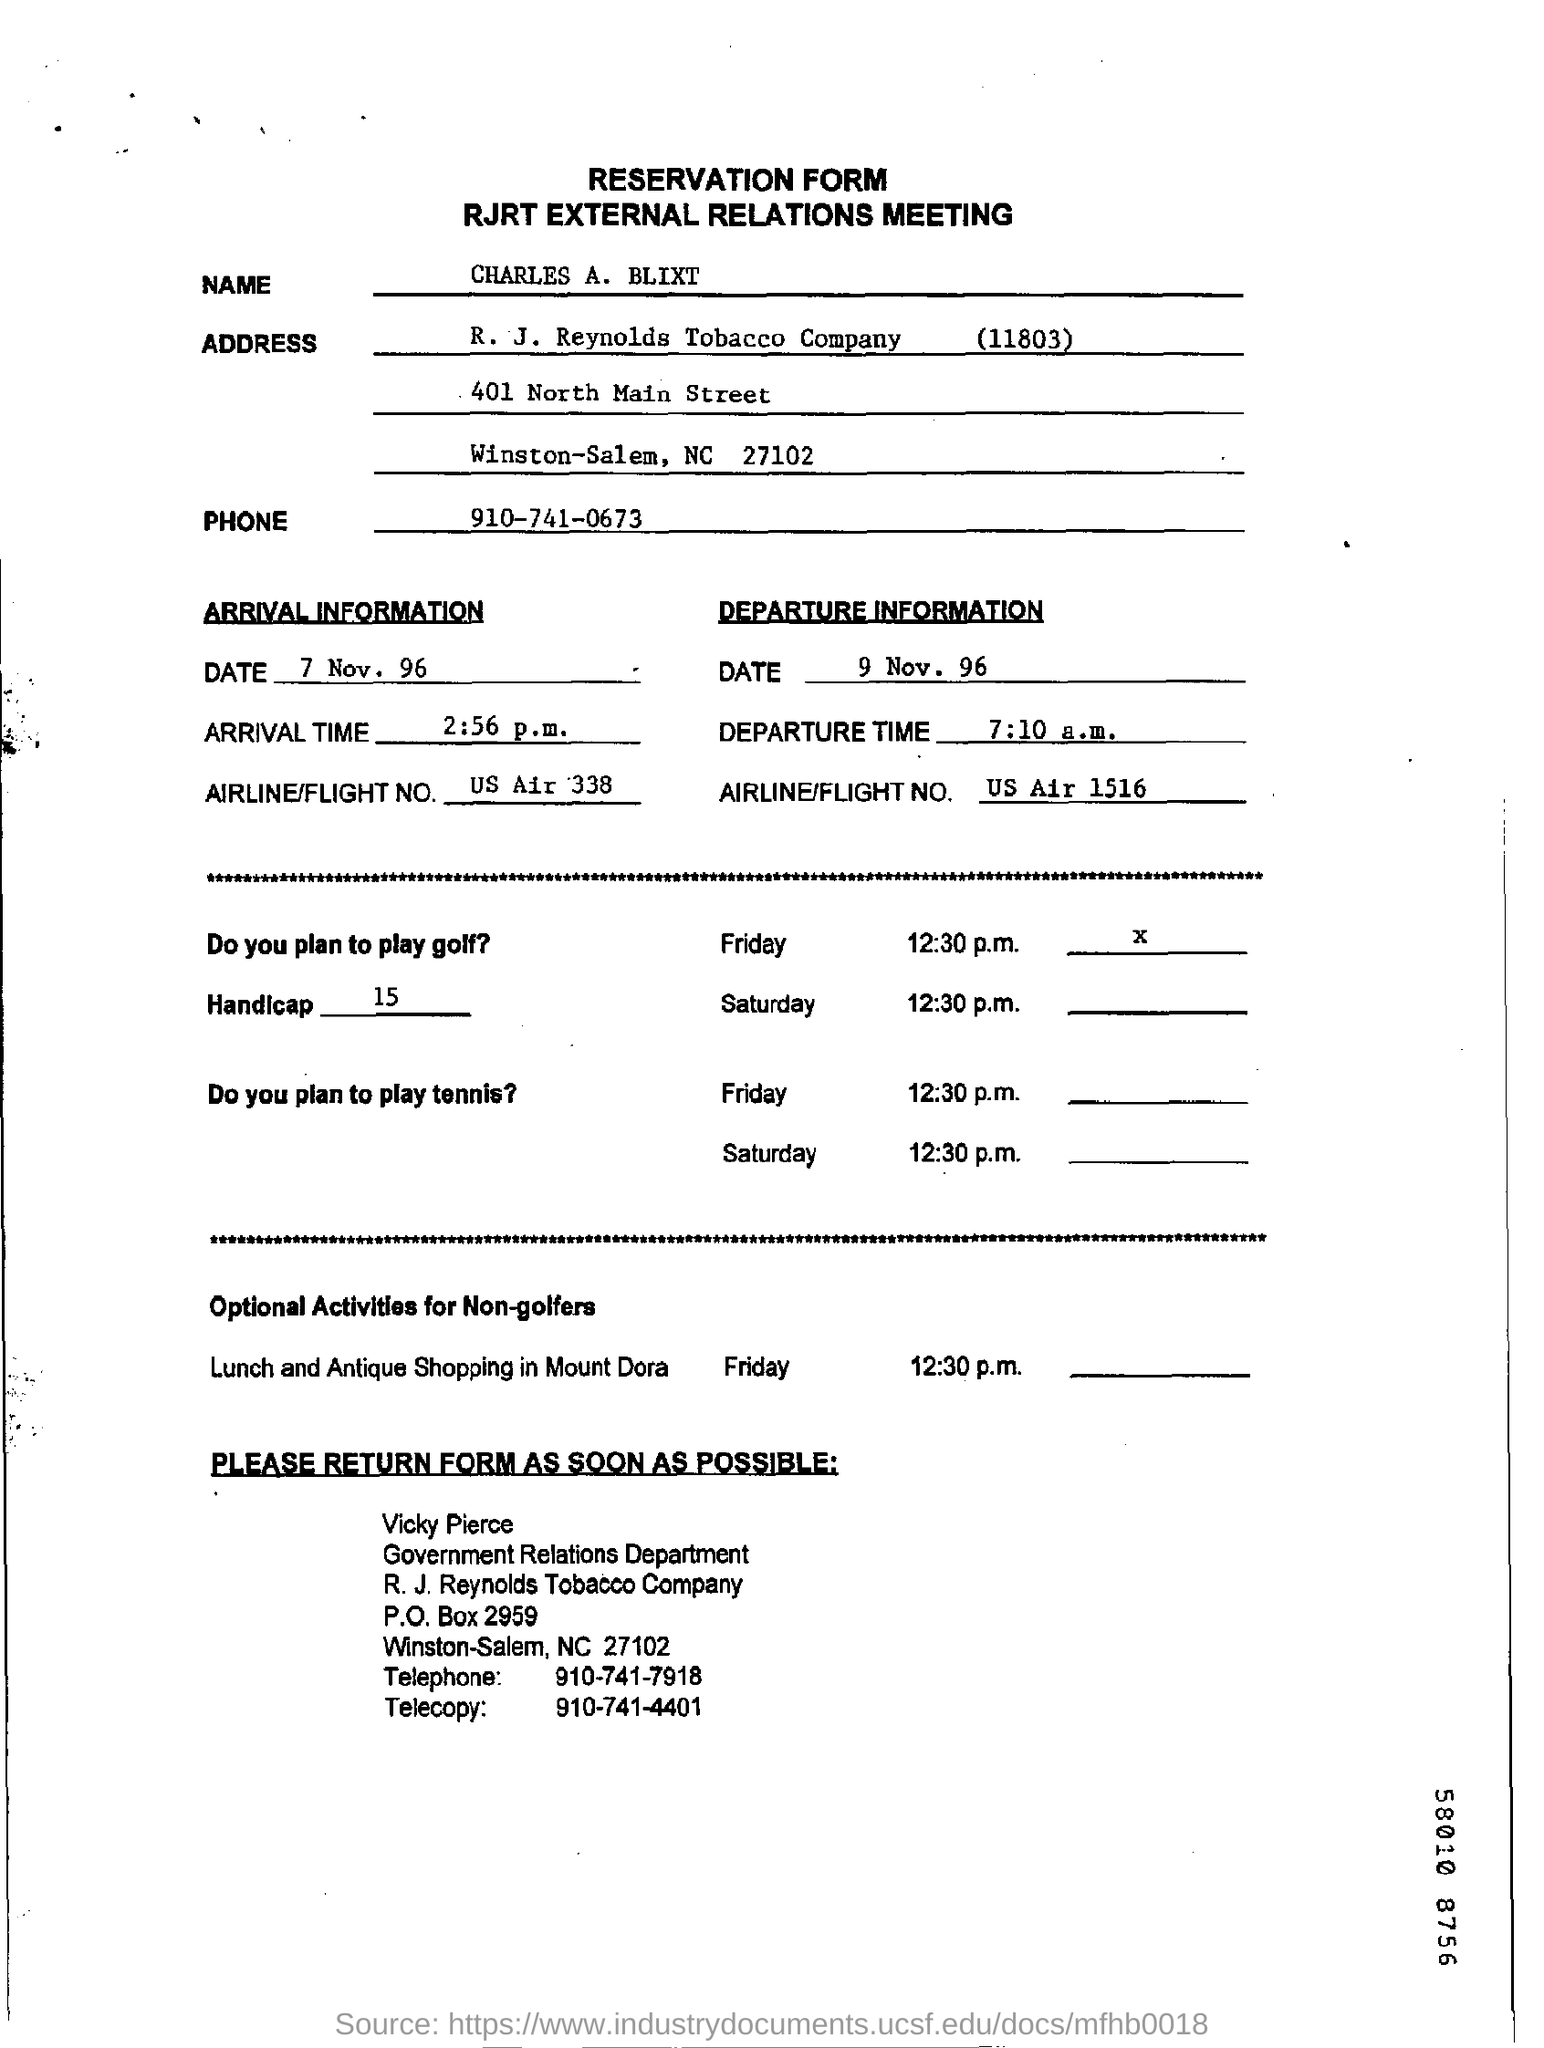Outline some significant characteristics in this image. The arrival time is 2:56 p.m. The date of departure is November 9th, 1996. The name is Charles A. Blixt. What is the date of arrival? On November 7th, 1996. The departure time is 7:10 a.m. 